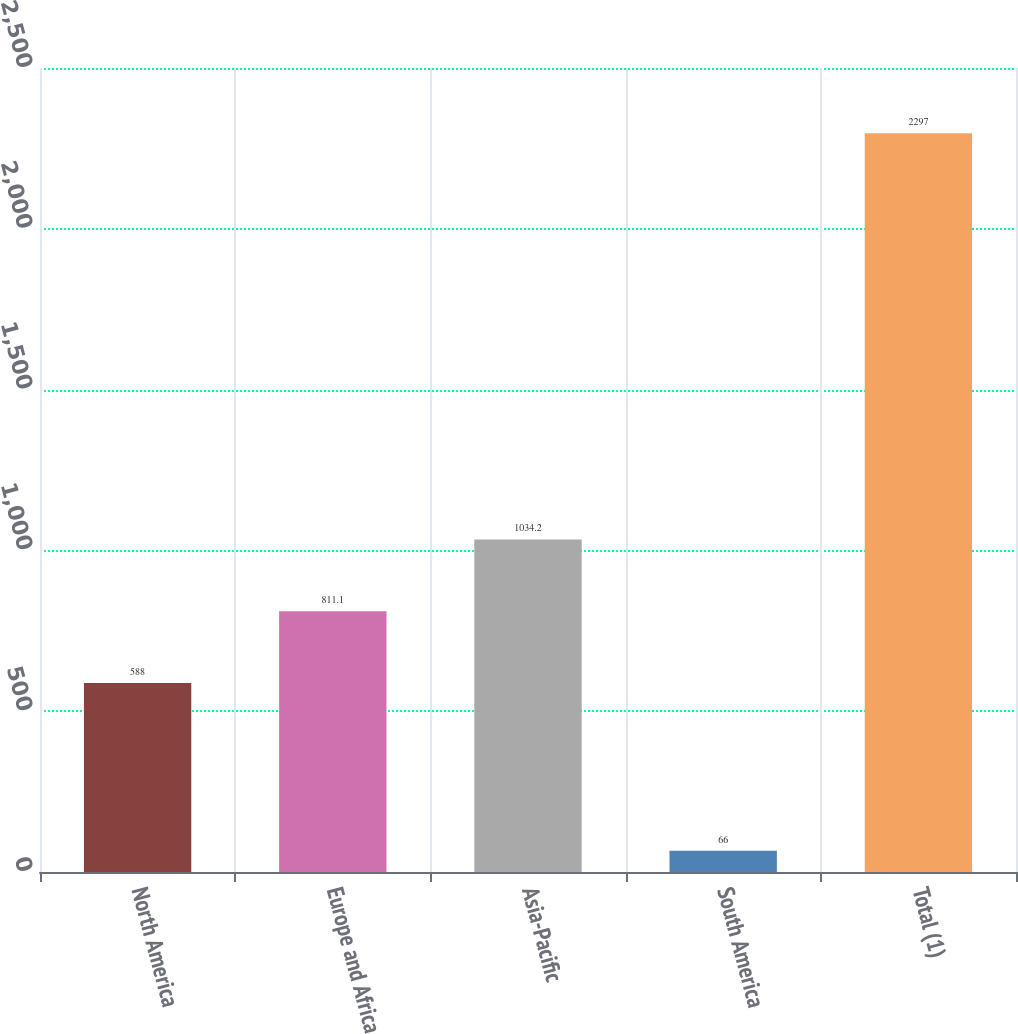Convert chart. <chart><loc_0><loc_0><loc_500><loc_500><bar_chart><fcel>North America<fcel>Europe and Africa<fcel>Asia-Pacific<fcel>South America<fcel>Total (1)<nl><fcel>588<fcel>811.1<fcel>1034.2<fcel>66<fcel>2297<nl></chart> 